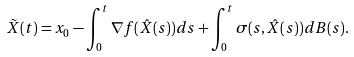<formula> <loc_0><loc_0><loc_500><loc_500>\tilde { X } ( t ) = x _ { 0 } - \int _ { 0 } ^ { t } \nabla f ( \hat { X } ( s ) ) d s + \int _ { 0 } ^ { t } \sigma ( s , \hat { X } ( s ) ) d B ( s ) .</formula> 